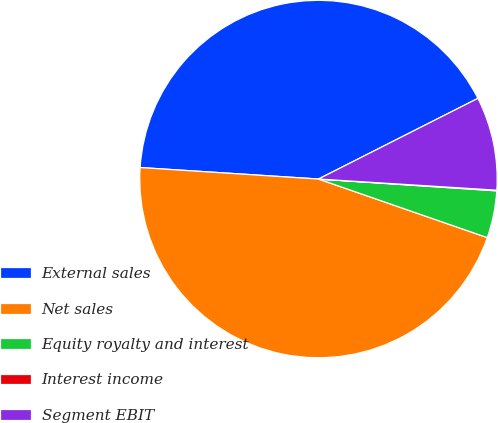Convert chart to OTSL. <chart><loc_0><loc_0><loc_500><loc_500><pie_chart><fcel>External sales<fcel>Net sales<fcel>Equity royalty and interest<fcel>Interest income<fcel>Segment EBIT<nl><fcel>41.52%<fcel>45.71%<fcel>4.26%<fcel>0.06%<fcel>8.45%<nl></chart> 